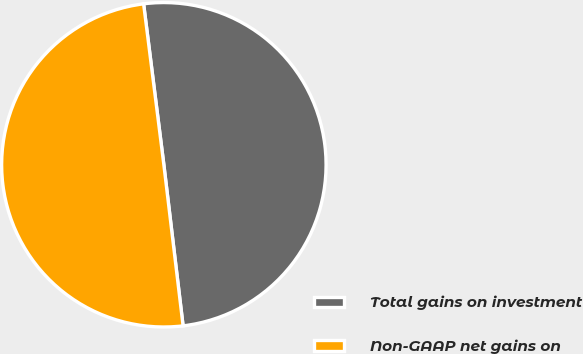Convert chart to OTSL. <chart><loc_0><loc_0><loc_500><loc_500><pie_chart><fcel>Total gains on investment<fcel>Non-GAAP net gains on<nl><fcel>50.1%<fcel>49.9%<nl></chart> 